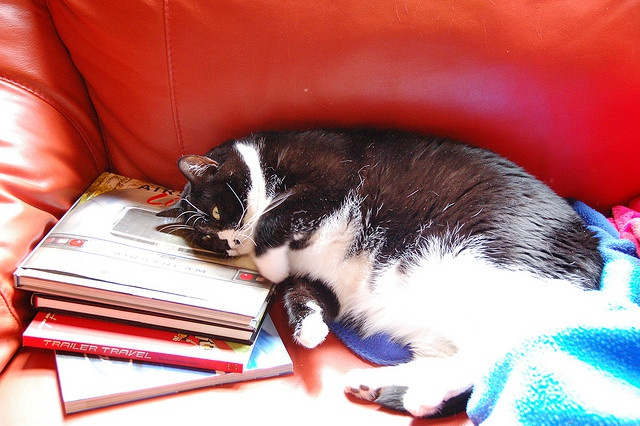Describe the objects in this image and their specific colors. I can see couch in red, brown, and white tones, cat in red, white, black, maroon, and gray tones, book in red, white, lightpink, brown, and maroon tones, book in red, white, lightpink, lightblue, and brown tones, and book in red, white, and brown tones in this image. 